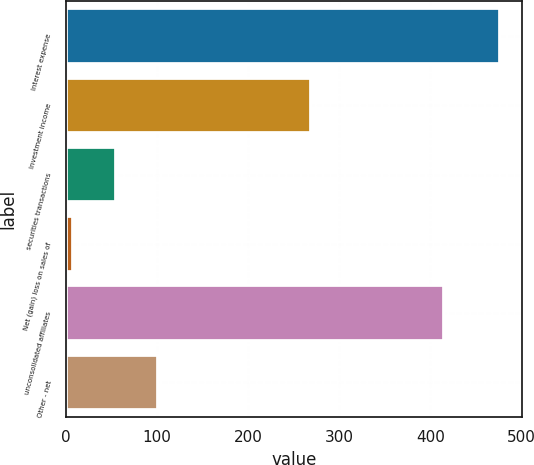<chart> <loc_0><loc_0><loc_500><loc_500><bar_chart><fcel>Interest expense<fcel>Investment income<fcel>securities transactions<fcel>Net (gain) loss on sales of<fcel>unconsolidated affiliates<fcel>Other - net<nl><fcel>477<fcel>269<fcel>54.9<fcel>8<fcel>415<fcel>101.8<nl></chart> 